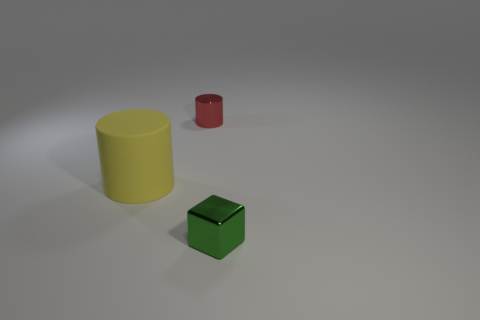There is a large yellow matte thing; is it the same shape as the tiny metal object behind the large object? yes 